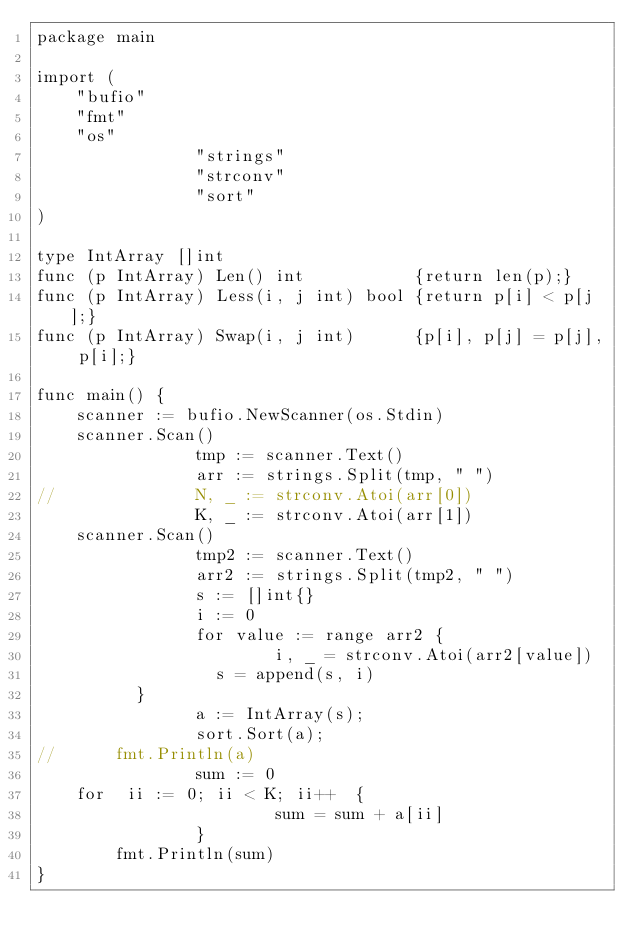Convert code to text. <code><loc_0><loc_0><loc_500><loc_500><_Go_>package main

import (
    "bufio"
    "fmt"
    "os"
                "strings"
                "strconv"
                "sort"
)

type IntArray []int
func (p IntArray) Len() int           {return len(p);}
func (p IntArray) Less(i, j int) bool {return p[i] < p[j];}
func (p IntArray) Swap(i, j int)      {p[i], p[j] = p[j], p[i];}

func main() {
    scanner := bufio.NewScanner(os.Stdin)
    scanner.Scan()
                tmp := scanner.Text()
                arr := strings.Split(tmp, " ")
//              N, _ := strconv.Atoi(arr[0])
                K, _ := strconv.Atoi(arr[1])
    scanner.Scan()
                tmp2 := scanner.Text()
                arr2 := strings.Split(tmp2, " ")
                s := []int{}
                i := 0
                for value := range arr2 {
                        i, _ = strconv.Atoi(arr2[value])
                  s = append(s, i)
          }
                a := IntArray(s);
                sort.Sort(a);
//      fmt.Println(a)
                sum := 0
    for  ii := 0; ii < K; ii++  {
                        sum = sum + a[ii]
                }
        fmt.Println(sum)
}</code> 